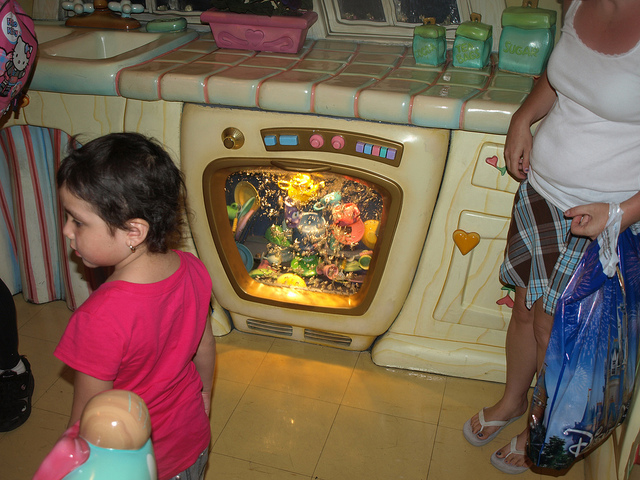How many children are in the photo? 1 